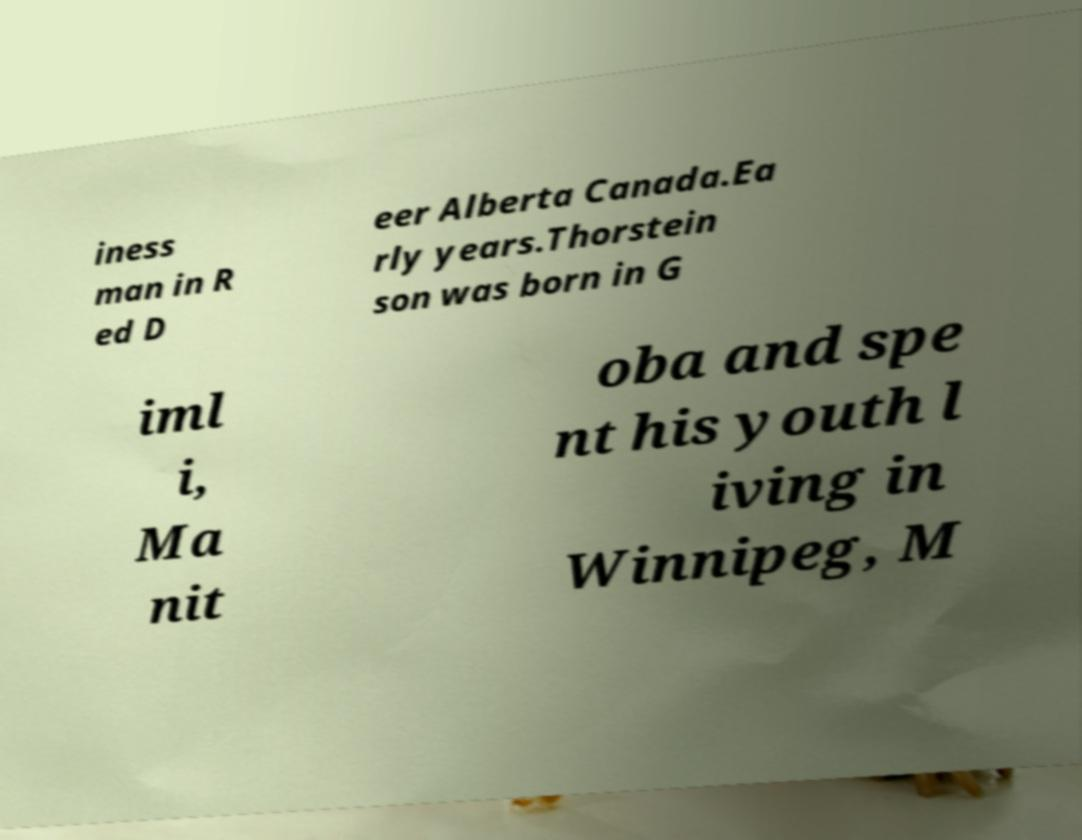Can you accurately transcribe the text from the provided image for me? iness man in R ed D eer Alberta Canada.Ea rly years.Thorstein son was born in G iml i, Ma nit oba and spe nt his youth l iving in Winnipeg, M 